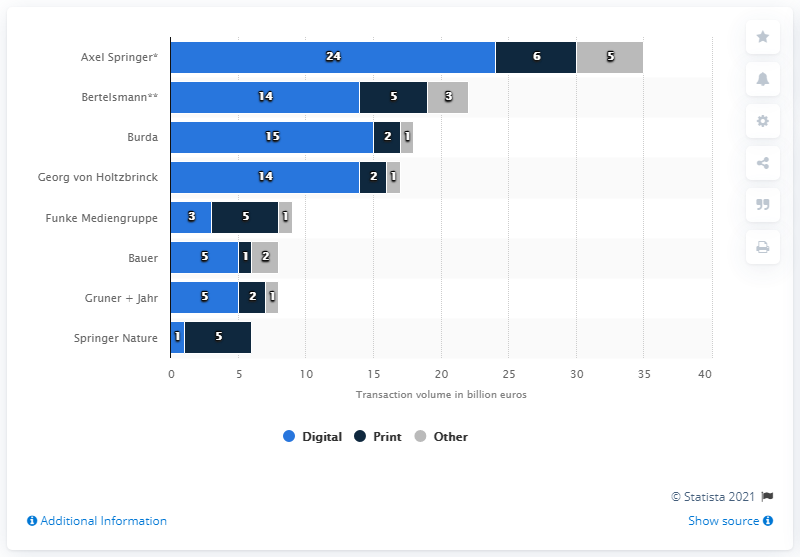Mention a couple of crucial points in this snapshot. The number of transactions in the digital segment was 24. 